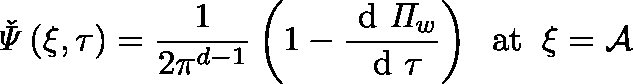Convert formula to latex. <formula><loc_0><loc_0><loc_500><loc_500>\check { \Psi } \left ( \xi , \tau \right ) = \frac { 1 } { 2 \pi ^ { d - 1 } } \left ( 1 - \frac { d \Pi _ { w } } { d \tau } \right ) \, a t \, \xi = \mathcal { A }</formula> 